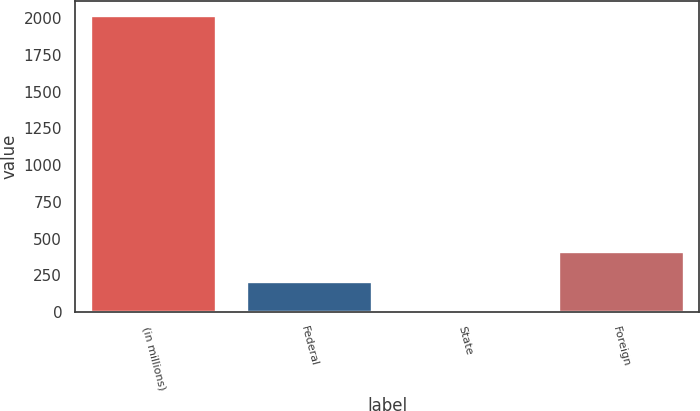Convert chart. <chart><loc_0><loc_0><loc_500><loc_500><bar_chart><fcel>(in millions)<fcel>Federal<fcel>State<fcel>Foreign<nl><fcel>2016<fcel>207<fcel>6<fcel>408<nl></chart> 